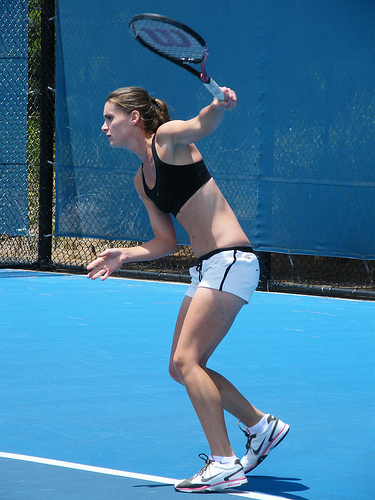What type of tennis court can be seen in the image? The tennis court in the image is a hard court, identifiable by its blue color and smooth, flat surface. 